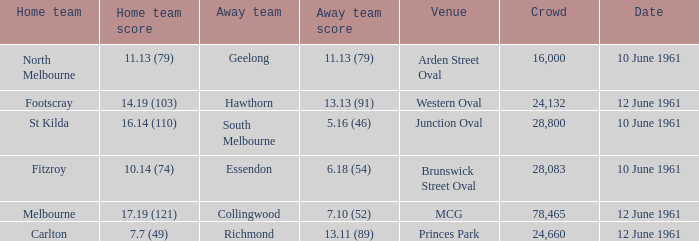What was the home team score for the Richmond away team? 7.7 (49). 